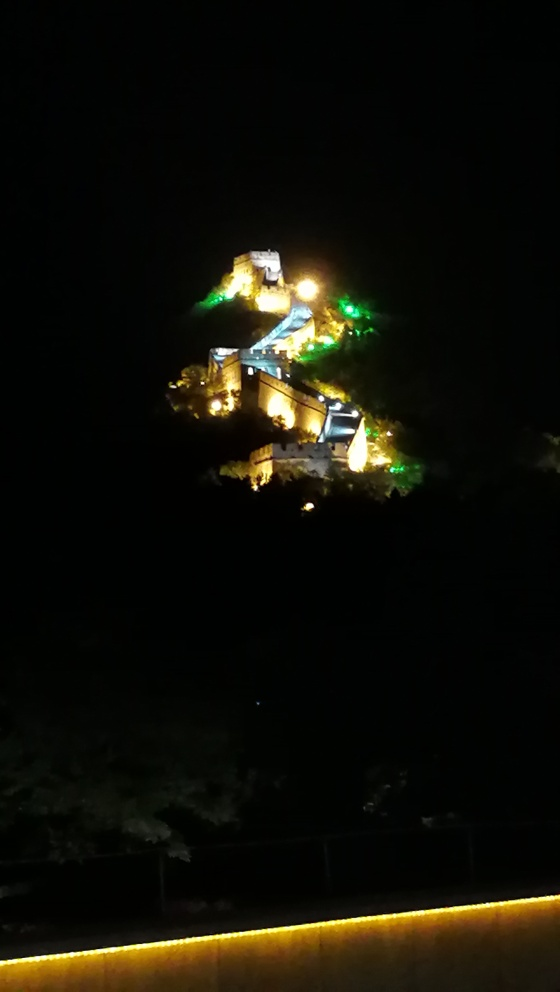What is the overall sharpness of this image?
A. Excellent
B. Average
C. Very poor
D. Good The image's overall sharpness is not very high due to the noticeable blurriness and lack of fine detail, particularly when observing the distant illuminated structure. The lighting conditions appear to be challenging, possibly leading to a lower shutter speed and therefore reduced sharpness. The right answer would be closer to 'C. Very poor,' though 'B. Average' might be considered depending on the observer's expectations for low-light photography. 